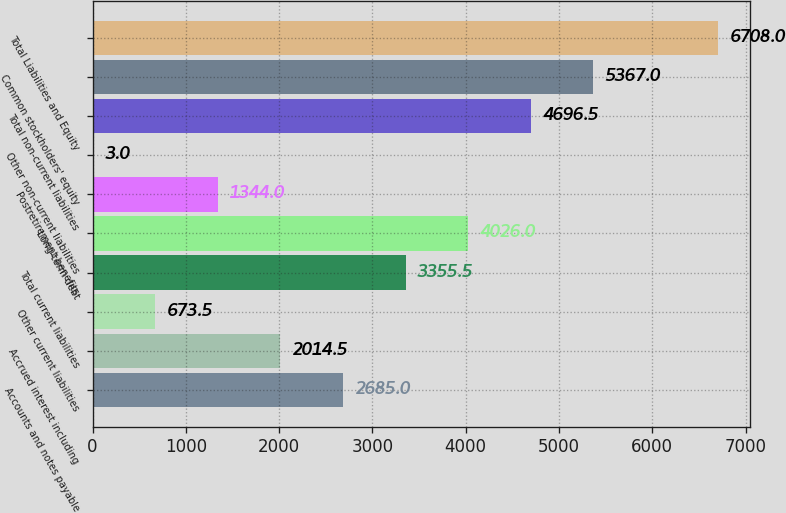Convert chart. <chart><loc_0><loc_0><loc_500><loc_500><bar_chart><fcel>Accounts and notes payable<fcel>Accrued interest including<fcel>Other current liabilities<fcel>Total current liabilities<fcel>Long-term debt<fcel>Postretirement benefits<fcel>Other non-current liabilities<fcel>Total non-current liabilities<fcel>Common stockholders' equity<fcel>Total Liabilities and Equity<nl><fcel>2685<fcel>2014.5<fcel>673.5<fcel>3355.5<fcel>4026<fcel>1344<fcel>3<fcel>4696.5<fcel>5367<fcel>6708<nl></chart> 